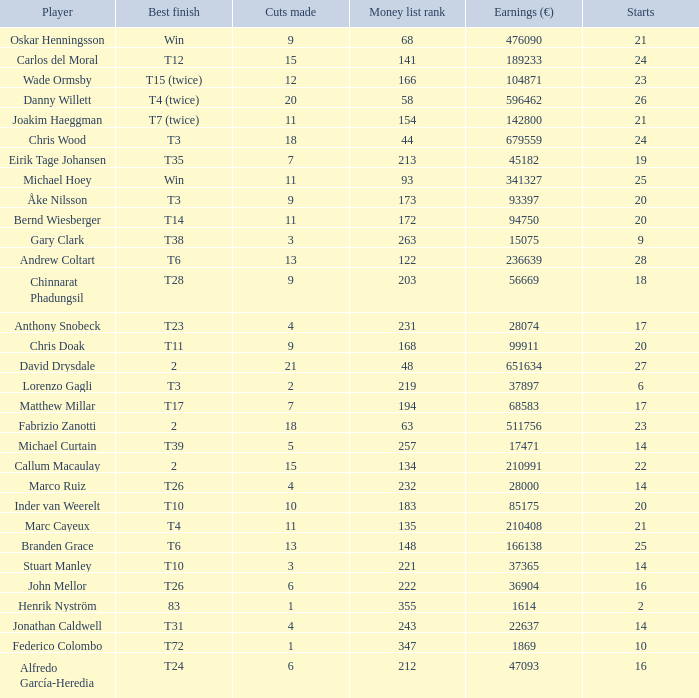Which player made exactly 26 starts? Danny Willett. 